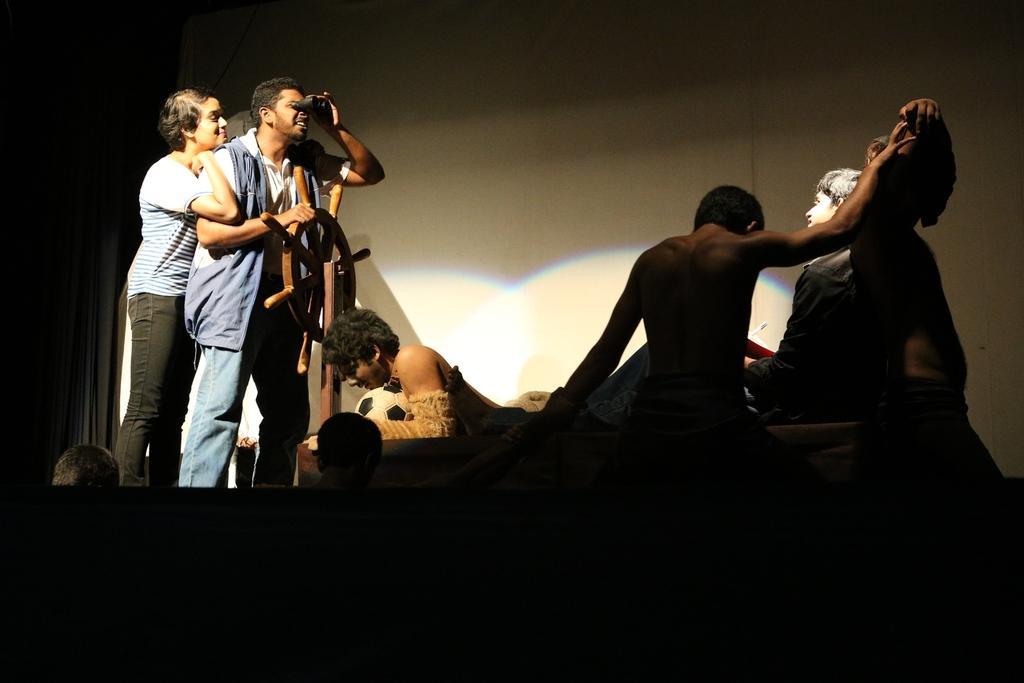Please provide a concise description of this image. This image is taken in the dark. I can see five people in here. Two people are standing towards the left side facing towards the right one person among them is holding a binoculars and a wheel in his hands. One person in the center of the image is holding a football. I can see a few more people at the bottom of the image. 